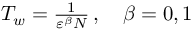Convert formula to latex. <formula><loc_0><loc_0><loc_500><loc_500>\begin{array} { r } { T _ { w } = \frac { 1 } { { \varepsilon } ^ { \beta } N } \, , \quad \beta = 0 , 1 } \end{array}</formula> 